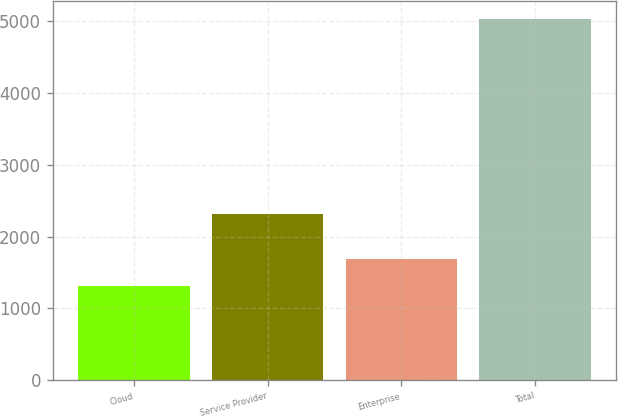Convert chart to OTSL. <chart><loc_0><loc_0><loc_500><loc_500><bar_chart><fcel>Cloud<fcel>Service Provider<fcel>Enterprise<fcel>Total<nl><fcel>1310.7<fcel>2319.4<fcel>1682.35<fcel>5027.2<nl></chart> 